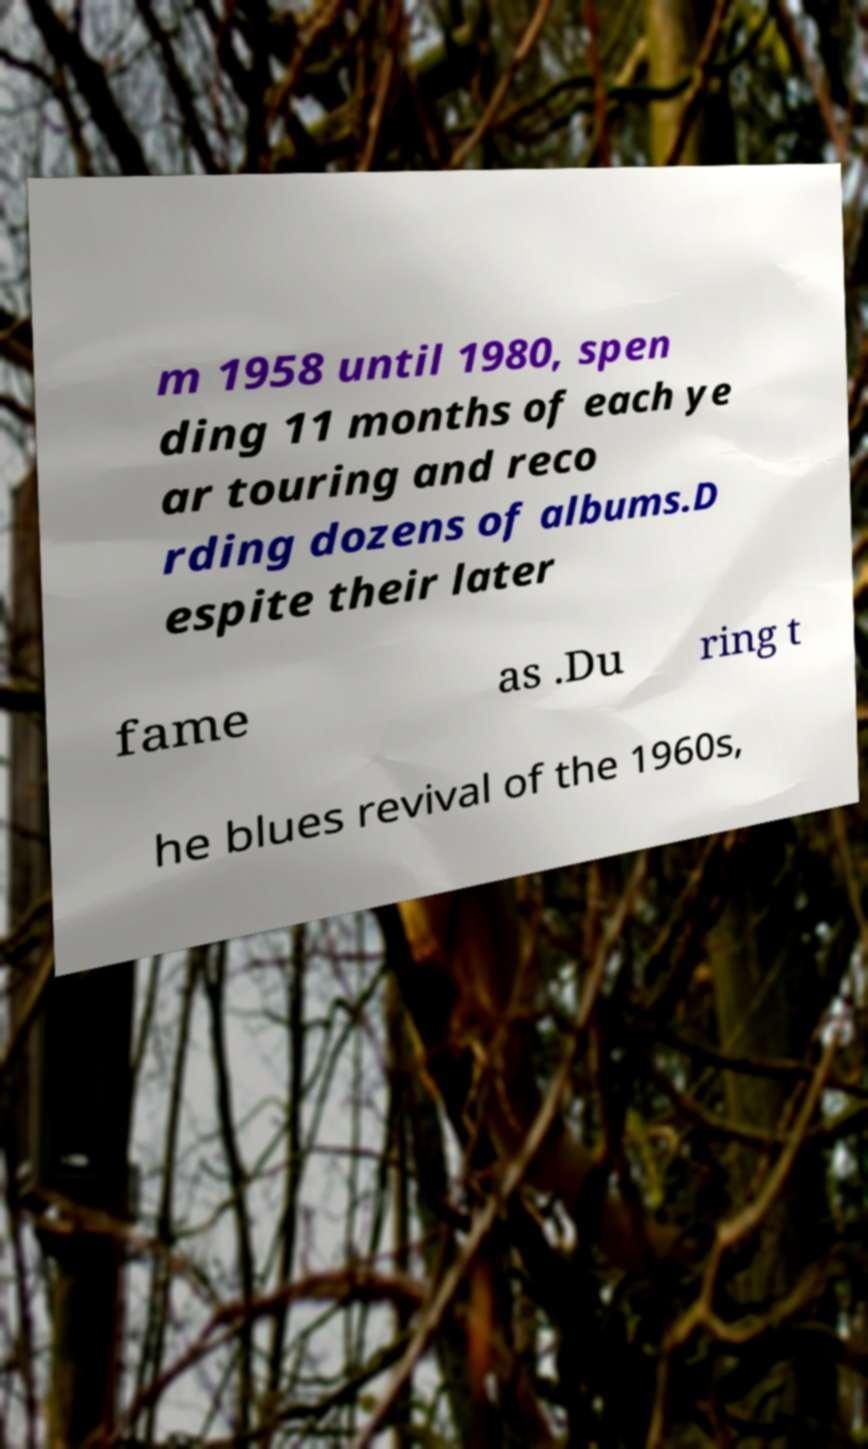Can you read and provide the text displayed in the image?This photo seems to have some interesting text. Can you extract and type it out for me? m 1958 until 1980, spen ding 11 months of each ye ar touring and reco rding dozens of albums.D espite their later fame as .Du ring t he blues revival of the 1960s, 